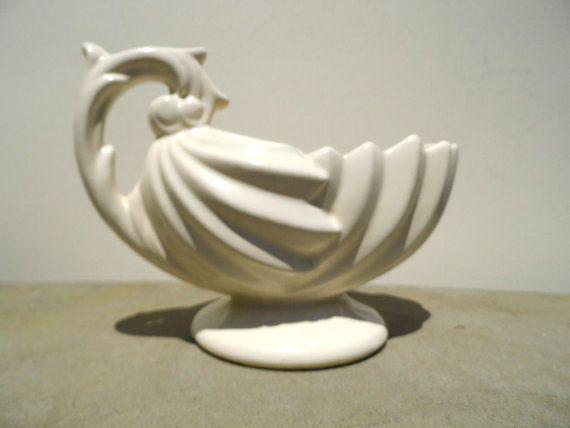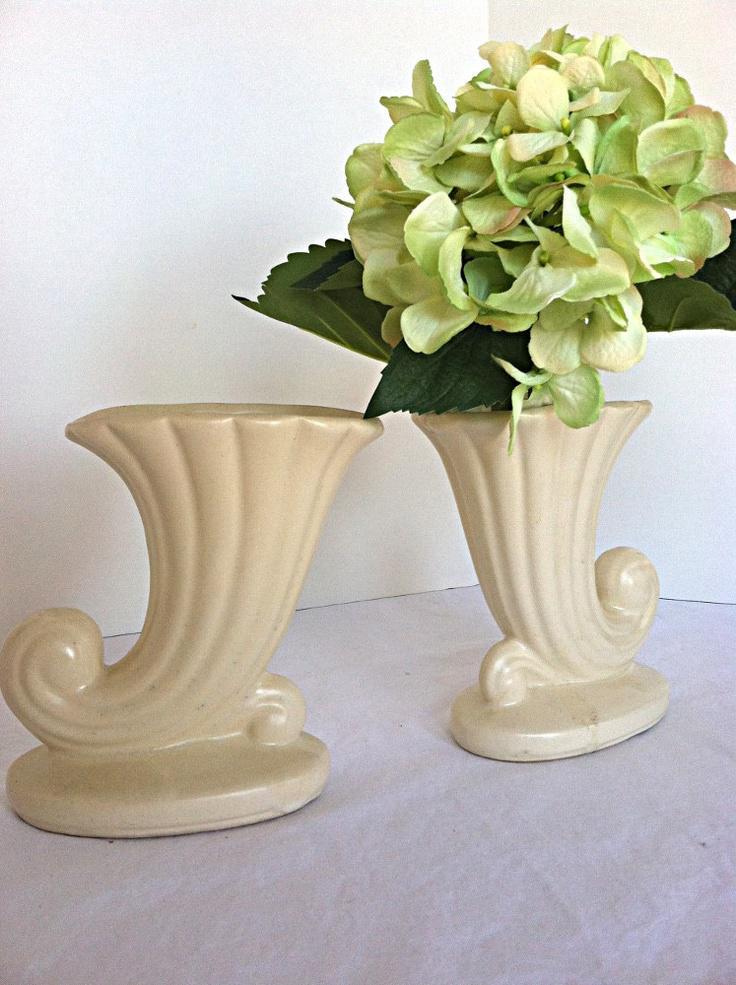The first image is the image on the left, the second image is the image on the right. For the images displayed, is the sentence "There is at least two vases in the right image." factually correct? Answer yes or no. Yes. The first image is the image on the left, the second image is the image on the right. Examine the images to the left and right. Is the description "An image shows a pair of vases designed with a curl shape at the bottom." accurate? Answer yes or no. Yes. 